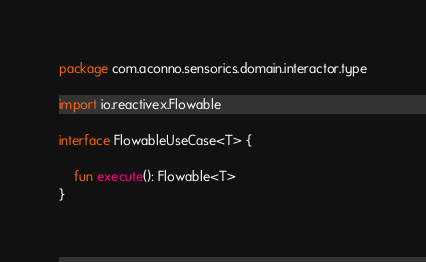<code> <loc_0><loc_0><loc_500><loc_500><_Kotlin_>package com.aconno.sensorics.domain.interactor.type

import io.reactivex.Flowable

interface FlowableUseCase<T> {

    fun execute(): Flowable<T>
}</code> 